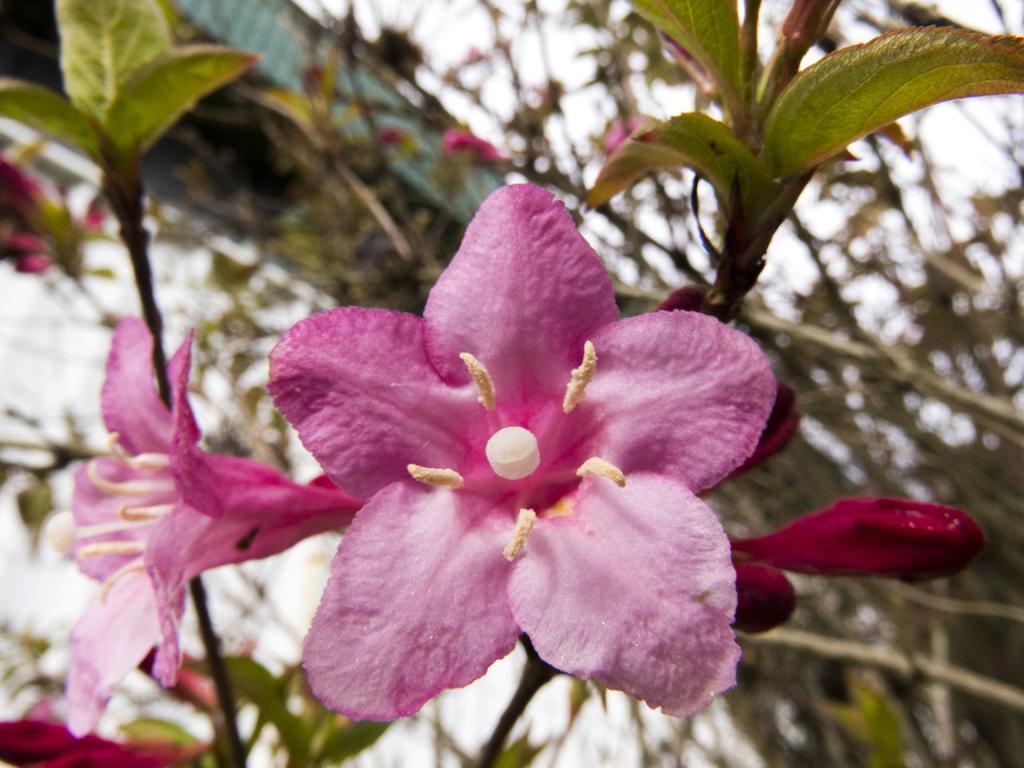Describe this image in one or two sentences. There are pink color flowers present in the middle of this image. It seems like there are some plants in the background. 